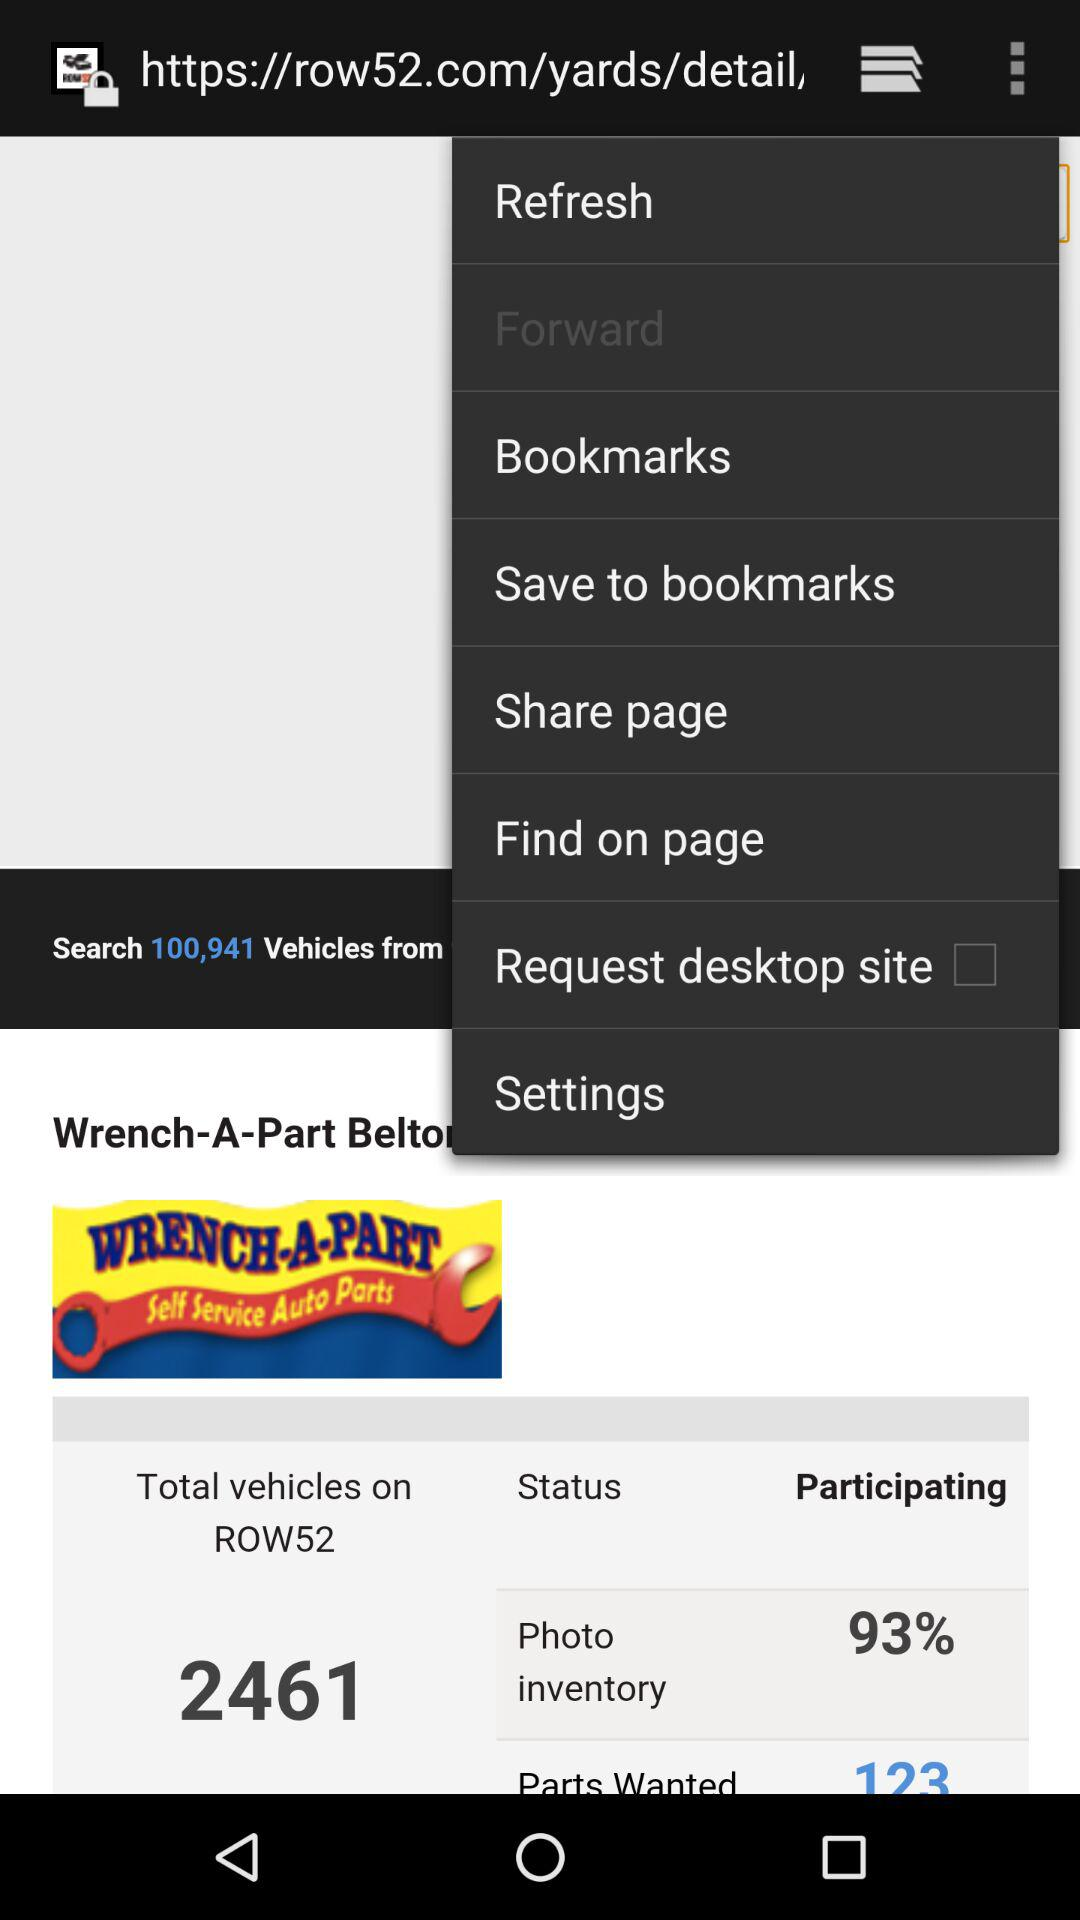What is the status of the "Request desktop site"? The status of the "Request desktop site" is "off". 